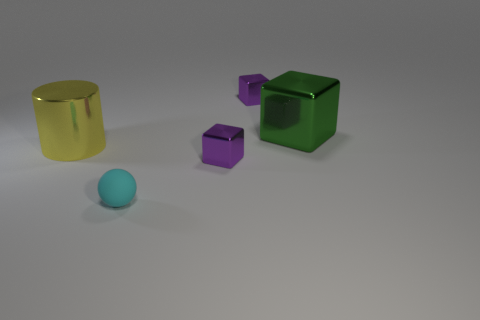Is there any other thing that has the same material as the cyan thing?
Ensure brevity in your answer.  No. What is the cyan ball that is in front of the large cube made of?
Your response must be concise. Rubber. Do the large thing left of the cyan ball and the big green block have the same material?
Your answer should be very brief. Yes. What number of objects are big green metallic spheres or metallic things that are on the right side of the tiny rubber sphere?
Provide a succinct answer. 3. There is a tiny matte thing; are there any large green cubes to the left of it?
Your answer should be compact. No. Do the large metal thing that is to the left of the cyan matte sphere and the small block behind the yellow thing have the same color?
Provide a short and direct response. No. Are there any small purple objects of the same shape as the large green shiny object?
Provide a short and direct response. Yes. What number of other things are there of the same color as the big cube?
Make the answer very short. 0. What is the color of the small object that is in front of the tiny purple metallic object that is in front of the large shiny thing that is behind the large yellow metallic thing?
Make the answer very short. Cyan. Are there the same number of tiny rubber objects to the left of the cylinder and tiny yellow matte balls?
Offer a terse response. Yes. 